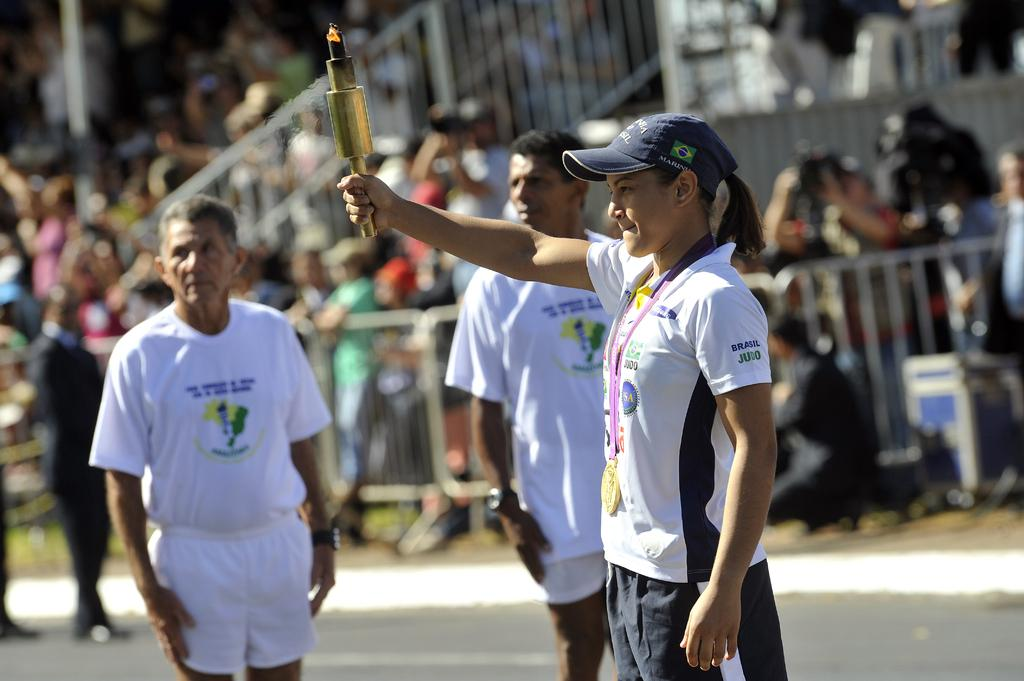How many people are in the image? There are people in the image, but the exact number is not specified. What is the person holding in the image? One person is holding an object that looks like a torch. Can you describe the background of the image? The background of the image is blurred. What type of advice can be heard from the waves in the image? There are no waves present in the image, so no advice can be heard from them. 